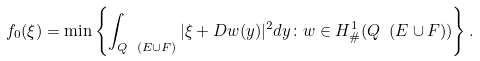<formula> <loc_0><loc_0><loc_500><loc_500>f _ { 0 } ( \xi ) = \min \left \{ \int _ { Q \ ( E \cup F ) } | \xi + D w ( y ) | ^ { 2 } d y \colon w \in H ^ { 1 } _ { \# } ( Q \ ( E \cup F ) ) \right \} .</formula> 